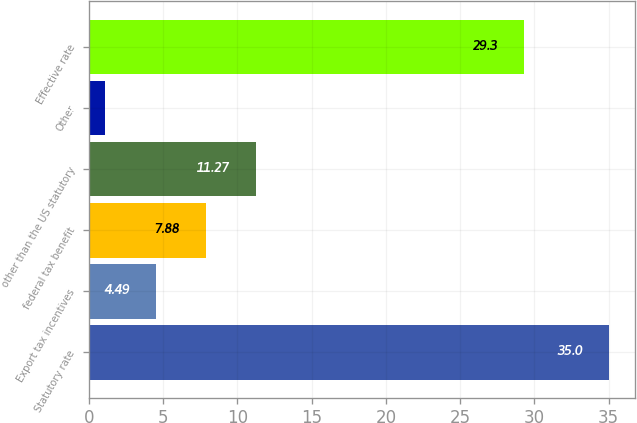Convert chart. <chart><loc_0><loc_0><loc_500><loc_500><bar_chart><fcel>Statutory rate<fcel>Export tax incentives<fcel>federal tax benefit<fcel>other than the US statutory<fcel>Other<fcel>Effective rate<nl><fcel>35<fcel>4.49<fcel>7.88<fcel>11.27<fcel>1.1<fcel>29.3<nl></chart> 